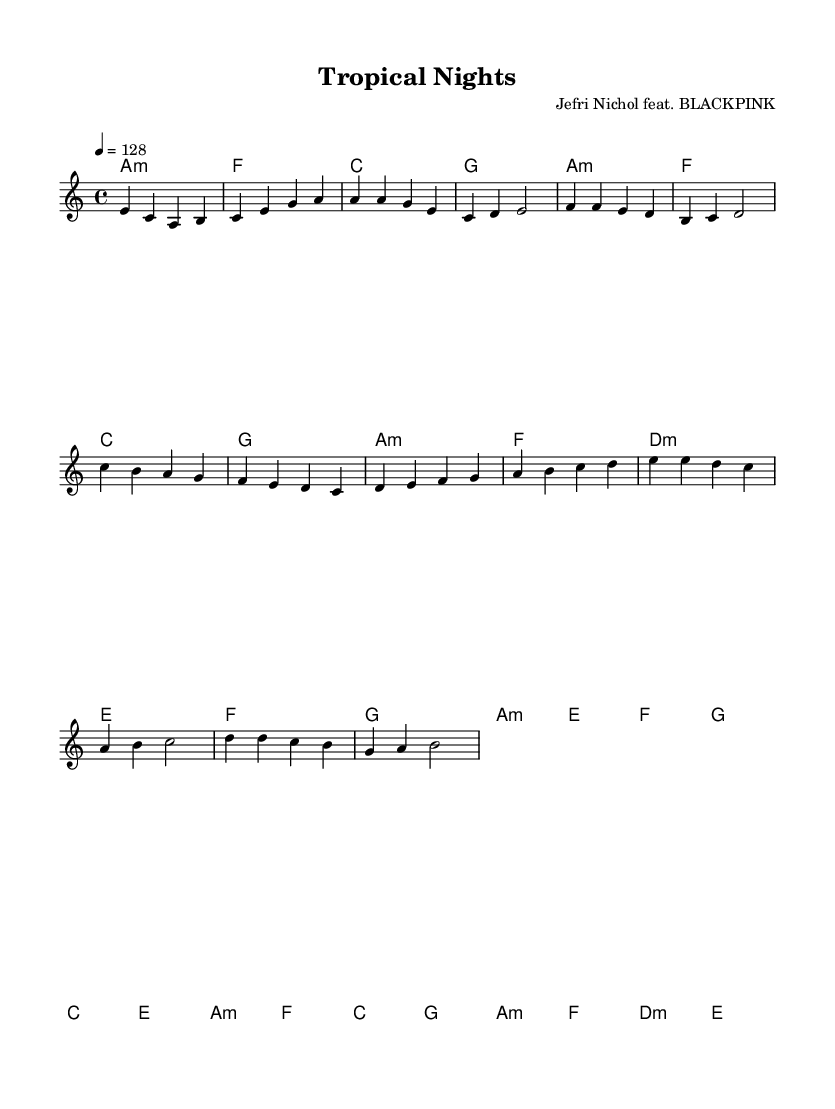What is the key signature of this music? The key signature is A minor, which has no sharps or flats. This can be identified by the information in the global section where "key a" is stated.
Answer: A minor What is the time signature of this music? The time signature is 4/4, which is indicated in the global section as "time 4/4." This means there are four beats in each measure and the quarter note gets one beat.
Answer: 4/4 What is the tempo marking for this piece? The tempo marking is 128 beats per minute (BPM), as mentioned in the global section: "tempo 4 = 128." This indicates the speed at which the piece should be played.
Answer: 128 How many measures are there in the chorus section? The chorus section contains 8 measures. By counting the specific musical segments laid out under the "Chorus" part, we see there are 8 distinct bars of music.
Answer: 8 What is the primary chord used in the introduction? The primary chord in the introduction is A minor. This is noted first in the harmonies section as "a1:m," indicating that A minor is the first chord played.
Answer: A minor Which K-Pop group collaborates in this piece? The collaborating K-Pop group is BLACKPINK, as stated in the header of the sheet music where it mentions "Jefri Nichol feat. BLACKPINK." This indicates that the piece features this popular K-Pop group.
Answer: BLACKPINK What is the name of this music piece? The name of this music piece is "Tropical Nights," which is explicitly given in the header section of the sheet music.
Answer: Tropical Nights 